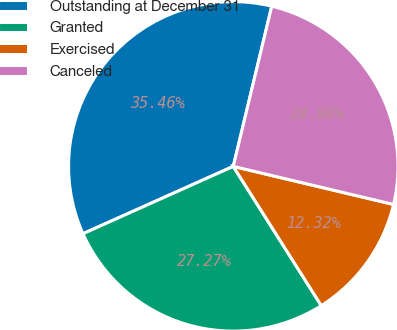<chart> <loc_0><loc_0><loc_500><loc_500><pie_chart><fcel>Outstanding at December 31<fcel>Granted<fcel>Exercised<fcel>Canceled<nl><fcel>35.46%<fcel>27.27%<fcel>12.32%<fcel>24.96%<nl></chart> 